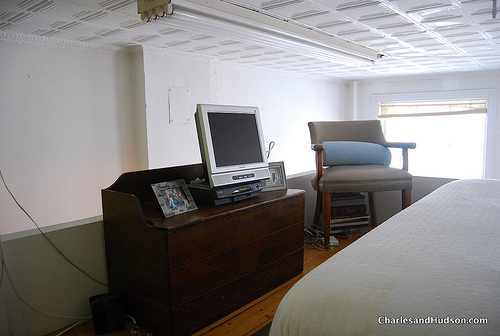Does the floor look dark? No, the flooring exhibits a relatively light wooden finish, giving a warm and light ambiance to the room. 